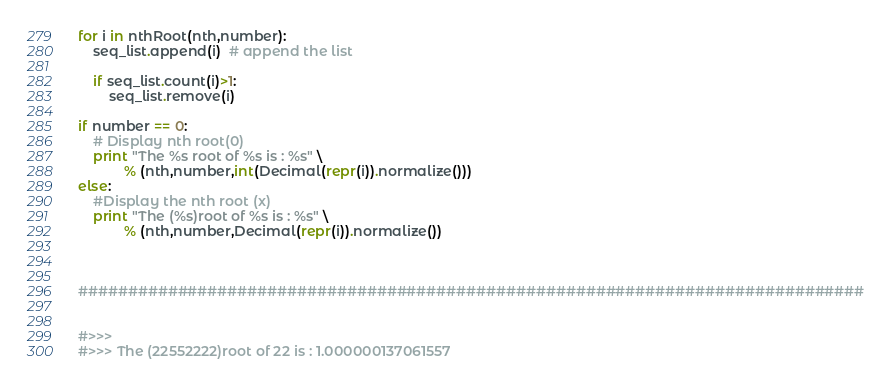Convert code to text. <code><loc_0><loc_0><loc_500><loc_500><_Python_>for i in nthRoot(nth,number):
    seq_list.append(i)  # append the list 
    
    if seq_list.count(i)>1: 
        seq_list.remove(i)
        
if number == 0:
    # Display nth root(0)
    print "The %s root of %s is : %s" \
            % (nth,number,int(Decimal(repr(i)).normalize()))          
else:
    #Display the nth root (x)
    print "The (%s)root of %s is : %s" \
            % (nth,number,Decimal(repr(i)).normalize())

  

###############################################################################
   

#>>> 
#>>> The (22552222)root of 22 is : 1.000000137061557</code> 